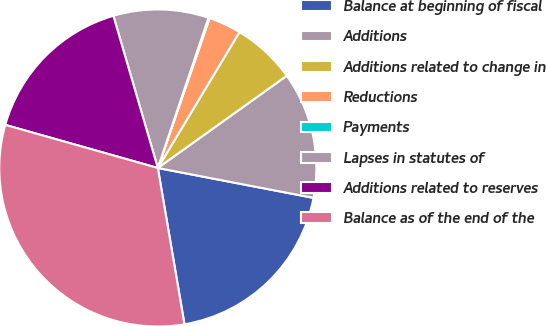Convert chart. <chart><loc_0><loc_0><loc_500><loc_500><pie_chart><fcel>Balance at beginning of fiscal<fcel>Additions<fcel>Additions related to change in<fcel>Reductions<fcel>Payments<fcel>Lapses in statutes of<fcel>Additions related to reserves<fcel>Balance as of the end of the<nl><fcel>19.29%<fcel>12.9%<fcel>6.51%<fcel>3.31%<fcel>0.12%<fcel>9.7%<fcel>16.09%<fcel>32.07%<nl></chart> 